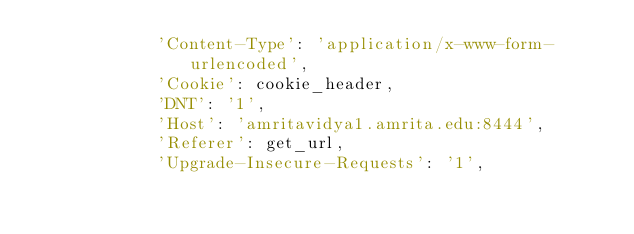<code> <loc_0><loc_0><loc_500><loc_500><_Python_>            'Content-Type': 'application/x-www-form-urlencoded',
            'Cookie': cookie_header,
            'DNT': '1',
            'Host': 'amritavidya1.amrita.edu:8444',
            'Referer': get_url,
            'Upgrade-Insecure-Requests': '1',</code> 